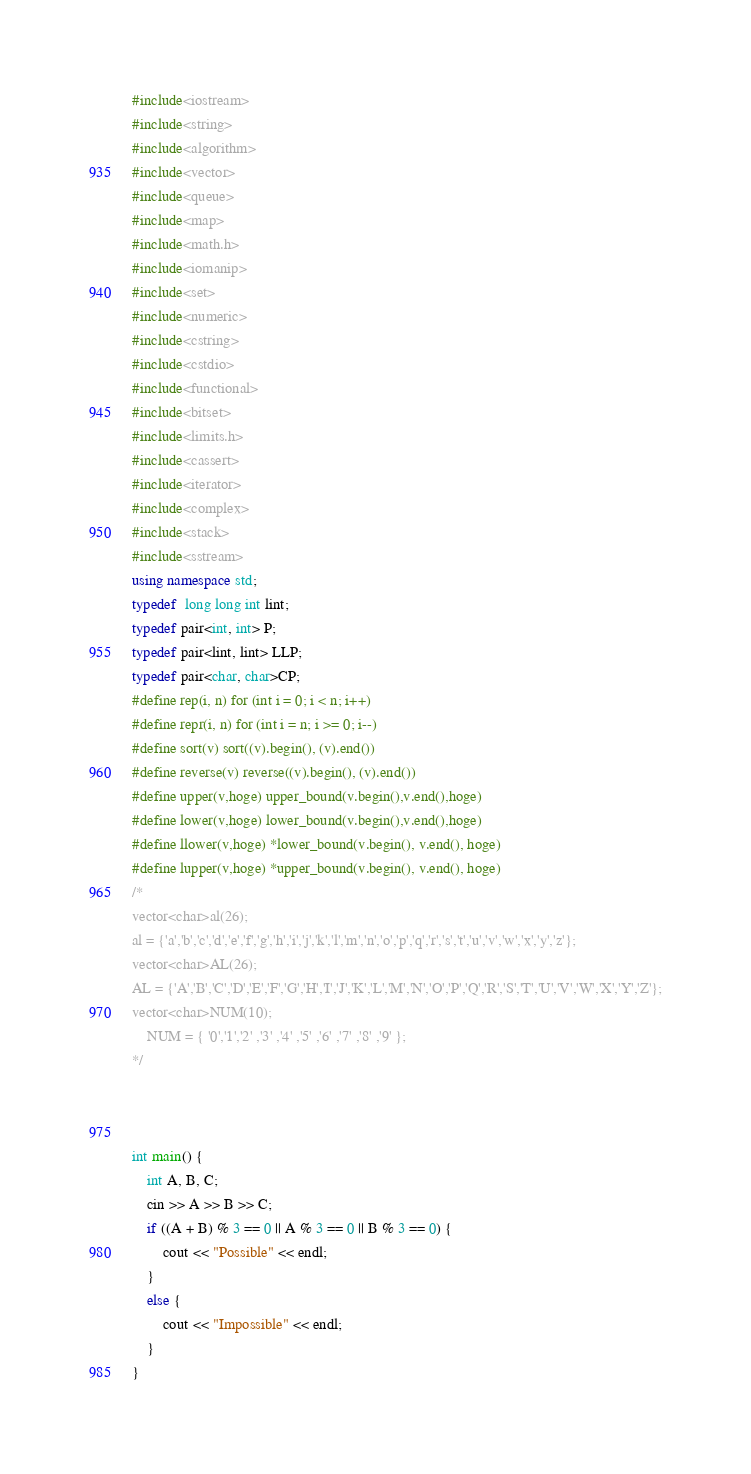<code> <loc_0><loc_0><loc_500><loc_500><_C++_>#include<iostream>
#include<string>
#include<algorithm>
#include<vector>
#include<queue>
#include<map>
#include<math.h>
#include<iomanip>
#include<set>
#include<numeric>
#include<cstring>
#include<cstdio>
#include<functional>
#include<bitset>
#include<limits.h>
#include<cassert>
#include<iterator>
#include<complex>
#include<stack>
#include<sstream>
using namespace std;
typedef  long long int lint;
typedef pair<int, int> P;
typedef pair<lint, lint> LLP;
typedef pair<char, char>CP;
#define rep(i, n) for (int i = 0; i < n; i++)
#define repr(i, n) for (int i = n; i >= 0; i--)
#define sort(v) sort((v).begin(), (v).end())
#define reverse(v) reverse((v).begin(), (v).end())
#define upper(v,hoge) upper_bound(v.begin(),v.end(),hoge)
#define lower(v,hoge) lower_bound(v.begin(),v.end(),hoge)
#define llower(v,hoge) *lower_bound(v.begin(), v.end(), hoge)
#define lupper(v,hoge) *upper_bound(v.begin(), v.end(), hoge)
/*
vector<char>al(26);
al = {'a','b','c','d','e','f','g','h','i','j','k','l','m','n','o','p','q','r','s','t','u','v','w','x','y','z'};
vector<char>AL(26);
AL = {'A','B','C','D','E','F','G','H','I','J','K','L','M','N','O','P','Q','R','S','T','U','V','W','X','Y','Z'};
vector<char>NUM(10);
	NUM = { '0','1','2' ,'3' ,'4' ,'5' ,'6' ,'7' ,'8' ,'9' };
*/



int main() {
	int A, B, C;
	cin >> A >> B >> C;
	if ((A + B) % 3 == 0 || A % 3 == 0 || B % 3 == 0) {
		cout << "Possible" << endl;
	}
	else {
		cout << "Impossible" << endl;
	}
}</code> 